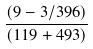<formula> <loc_0><loc_0><loc_500><loc_500>\frac { ( 9 - 3 / 3 9 6 ) } { ( 1 1 9 + 4 9 3 ) }</formula> 